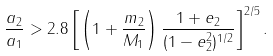<formula> <loc_0><loc_0><loc_500><loc_500>\frac { a _ { 2 } } { a _ { 1 } } > 2 . 8 \left [ \left ( 1 + \frac { m _ { 2 } } { M _ { 1 } } \right ) \frac { 1 + e _ { 2 } } { ( 1 - e ^ { 2 } _ { 2 } ) ^ { 1 / 2 } } \right ] ^ { 2 / 5 } .</formula> 